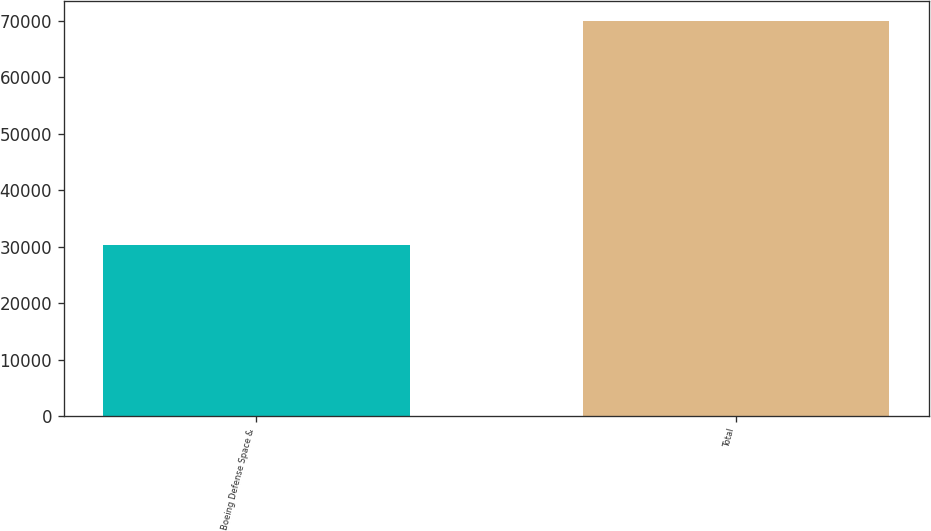Convert chart to OTSL. <chart><loc_0><loc_0><loc_500><loc_500><bar_chart><fcel>Boeing Defense Space &<fcel>Total<nl><fcel>30356<fcel>69902<nl></chart> 